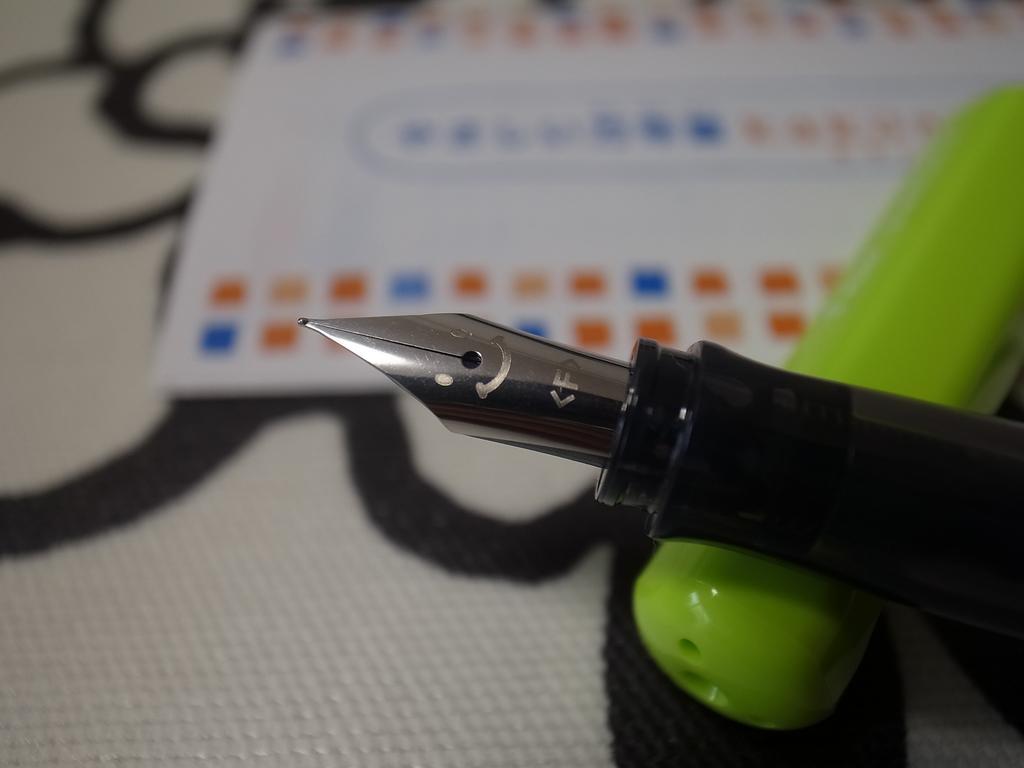How would you summarize this image in a sentence or two? In this image we can see a pen nib, there is some green color object on the surface, beside there is a paper, there it is in black and white. 